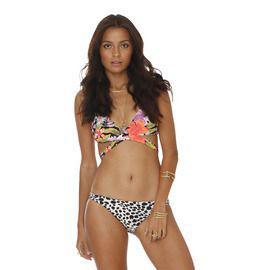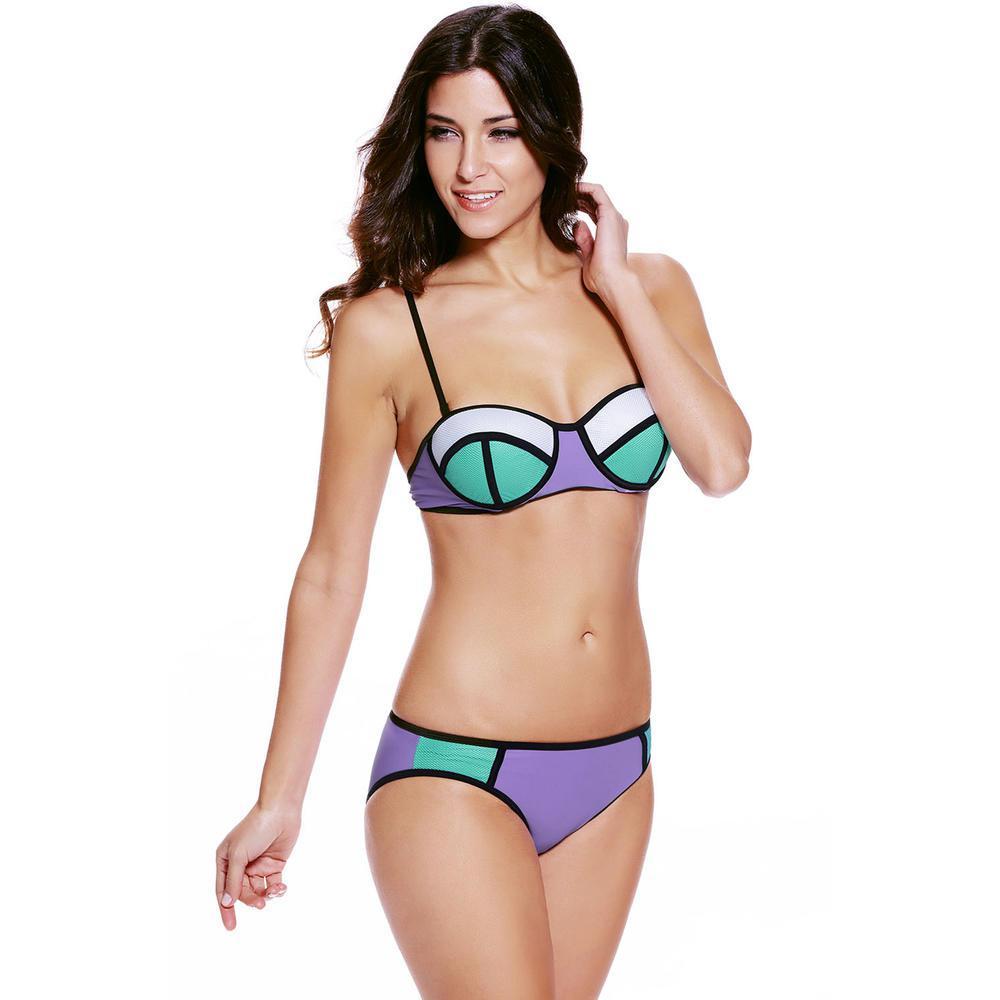The first image is the image on the left, the second image is the image on the right. Examine the images to the left and right. Is the description "One woman has her hand on her hip." accurate? Answer yes or no. No. The first image is the image on the left, the second image is the image on the right. For the images shown, is this caption "At least one model wears a bikini with completely different patterns on the top and bottom." true? Answer yes or no. Yes. 